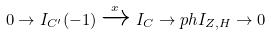Convert formula to latex. <formula><loc_0><loc_0><loc_500><loc_500>0 \to I _ { C ^ { \prime } } ( - 1 ) \xrightarrow { x } I _ { C } \to p h I _ { Z , H } \to 0</formula> 